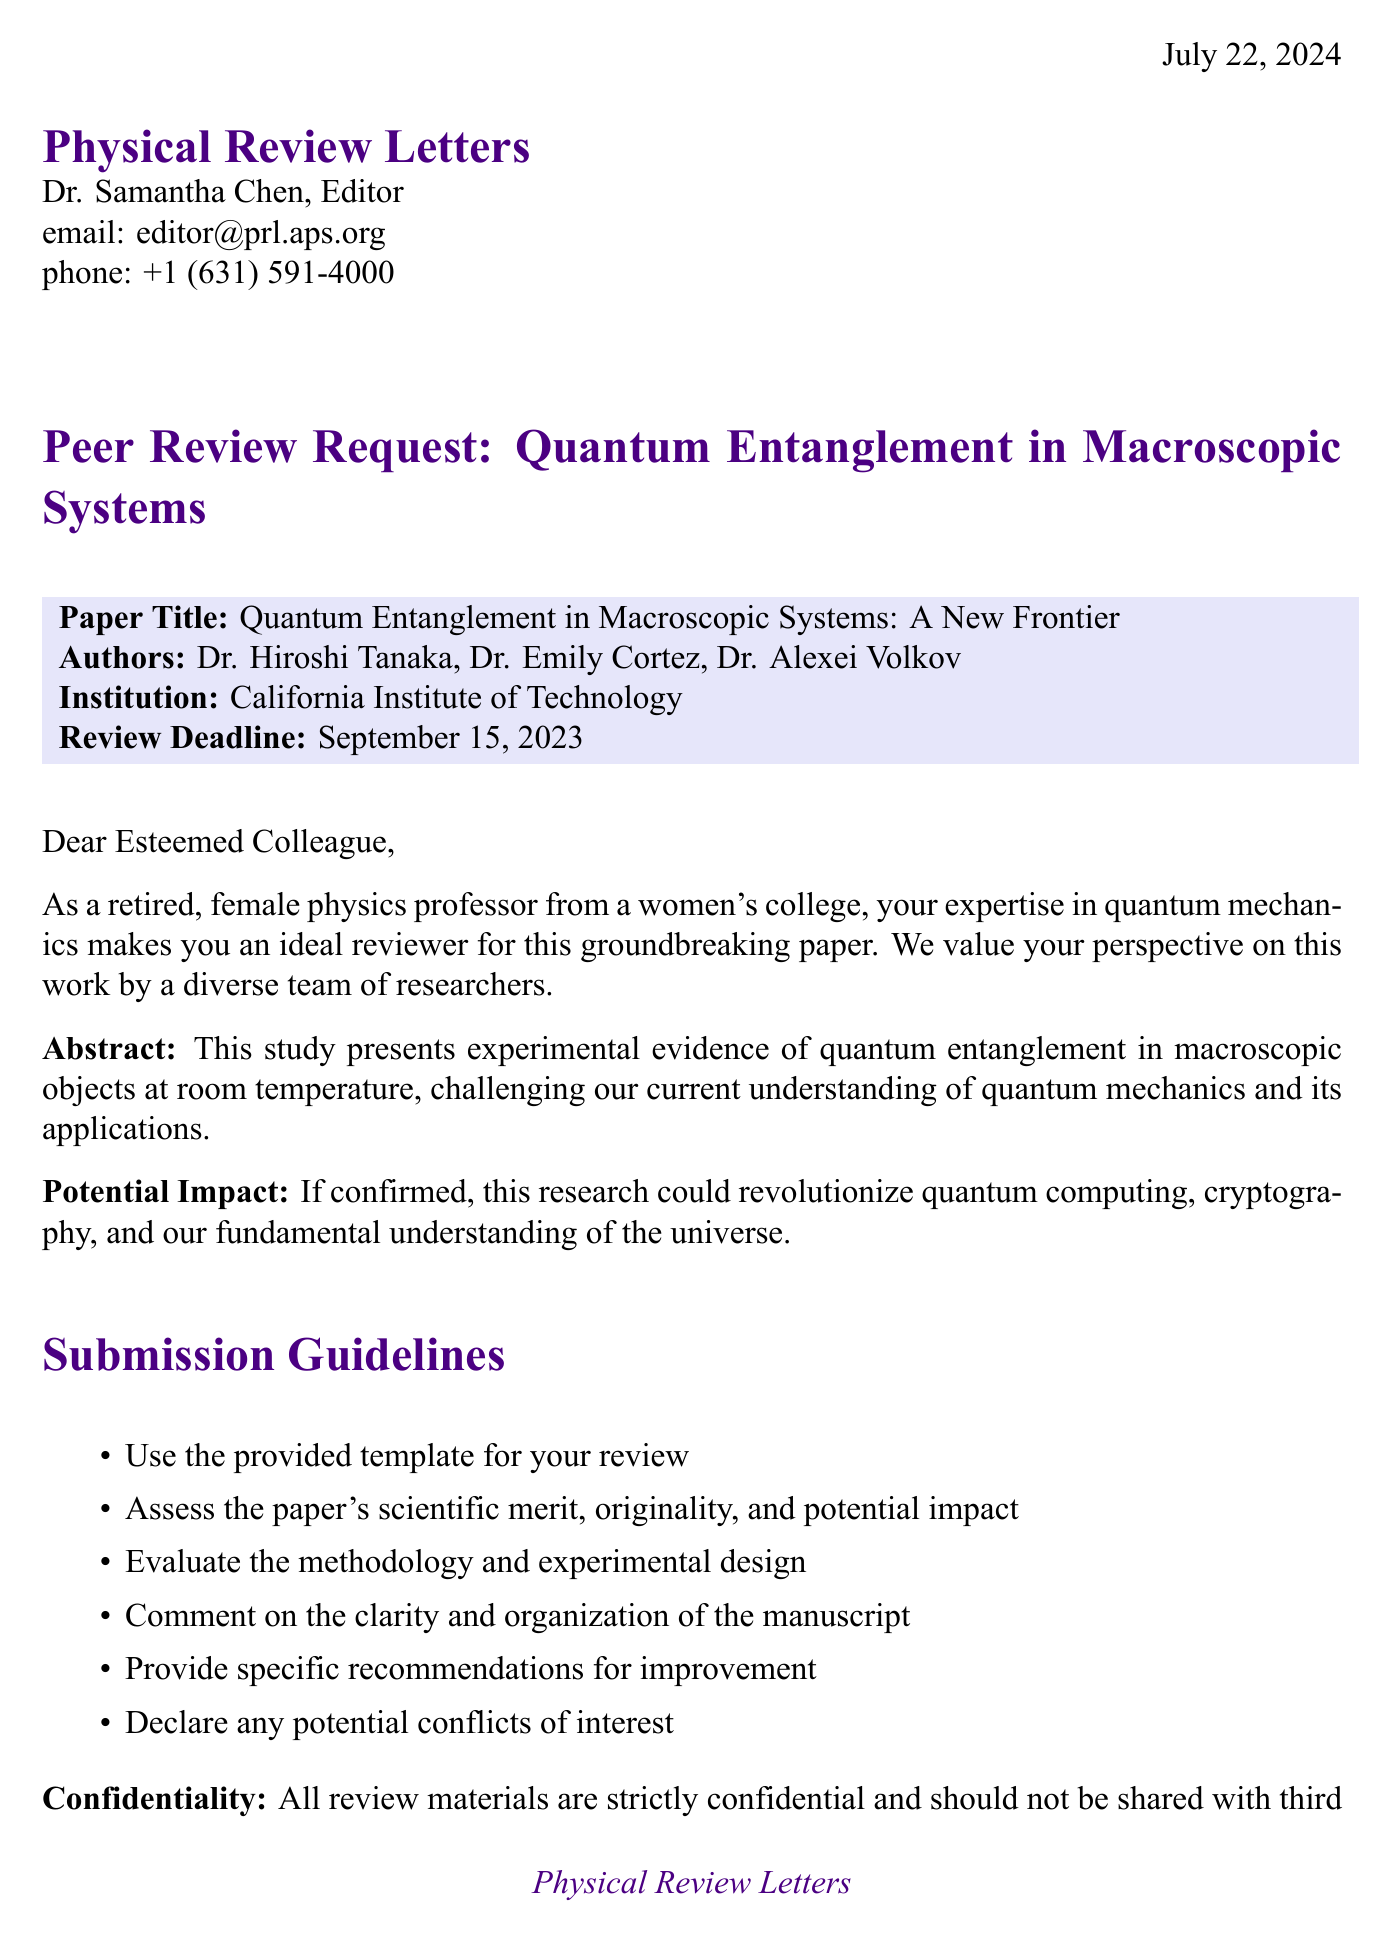What is the name of the journal? The journal's name is stated prominently at the top of the document.
Answer: Physical Review Letters Who is the editor of the journal? The letter mentions Dr. Samantha Chen as the editor of the journal.
Answer: Dr. Samantha Chen What is the title of the paper to be reviewed? The title of the paper is highlighted in the first section of the letter.
Answer: Quantum Entanglement in Macroscopic Systems: A New Frontier What is the review deadline? The review deadline is explicitly stated within the letter.
Answer: September 15, 2023 What are reviewers asked to assess in their review? The guidelines include several areas that need to be assessed, as listed in the document.
Answer: Scientific merit, originality, and potential impact What is one of the potential impacts of the research? The letter describes a significant potential impact of the research if confirmed.
Answer: Revolutionize quantum computing, cryptography, and our fundamental understanding of the universe What is the offered compensation for the review? The letter specifies the compensation provided to reviewers in return for their work.
Answer: A complimentary one-year subscription to Physical Review Letters What should reviewers declare in their review? The document outlines an important requirement for reviewers regarding transparency.
Answer: Any potential conflicts of interest What additional resources will reviewers have access to? The letter outlines the additional resources available to reviewers during the review process.
Answer: Access to the journal's online review system What is the journal's impact factor? The document mentions the journal's impact factor as part of the compensation section.
Answer: 8.385 